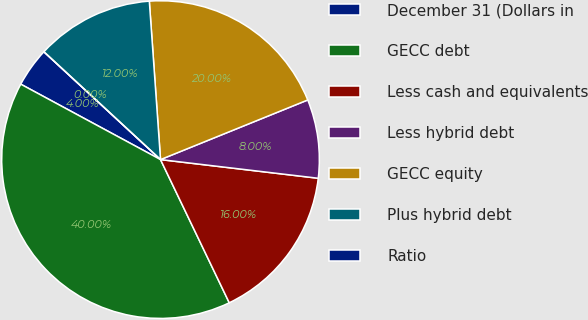<chart> <loc_0><loc_0><loc_500><loc_500><pie_chart><fcel>December 31 (Dollars in<fcel>GECC debt<fcel>Less cash and equivalents<fcel>Less hybrid debt<fcel>GECC equity<fcel>Plus hybrid debt<fcel>Ratio<nl><fcel>4.0%<fcel>40.0%<fcel>16.0%<fcel>8.0%<fcel>20.0%<fcel>12.0%<fcel>0.0%<nl></chart> 